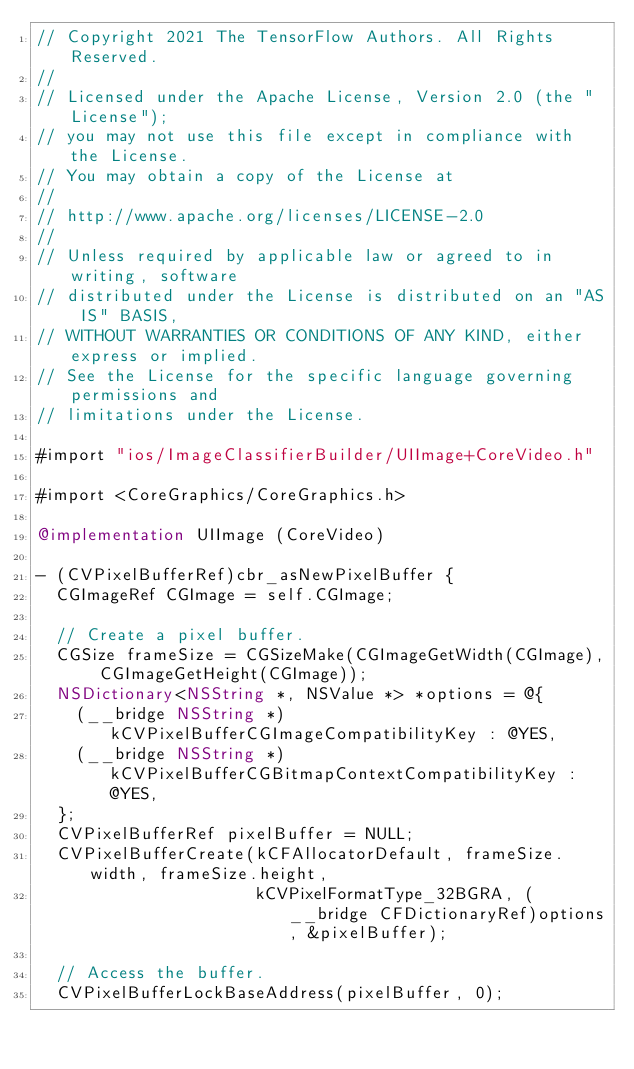Convert code to text. <code><loc_0><loc_0><loc_500><loc_500><_ObjectiveC_>// Copyright 2021 The TensorFlow Authors. All Rights Reserved.
//
// Licensed under the Apache License, Version 2.0 (the "License");
// you may not use this file except in compliance with the License.
// You may obtain a copy of the License at
//
// http://www.apache.org/licenses/LICENSE-2.0
//
// Unless required by applicable law or agreed to in writing, software
// distributed under the License is distributed on an "AS IS" BASIS,
// WITHOUT WARRANTIES OR CONDITIONS OF ANY KIND, either express or implied.
// See the License for the specific language governing permissions and
// limitations under the License.

#import "ios/ImageClassifierBuilder/UIImage+CoreVideo.h"

#import <CoreGraphics/CoreGraphics.h>

@implementation UIImage (CoreVideo)

- (CVPixelBufferRef)cbr_asNewPixelBuffer {
  CGImageRef CGImage = self.CGImage;

  // Create a pixel buffer.
  CGSize frameSize = CGSizeMake(CGImageGetWidth(CGImage), CGImageGetHeight(CGImage));
  NSDictionary<NSString *, NSValue *> *options = @{
    (__bridge NSString *)kCVPixelBufferCGImageCompatibilityKey : @YES,
    (__bridge NSString *)kCVPixelBufferCGBitmapContextCompatibilityKey : @YES,
  };
  CVPixelBufferRef pixelBuffer = NULL;
  CVPixelBufferCreate(kCFAllocatorDefault, frameSize.width, frameSize.height,
                      kCVPixelFormatType_32BGRA, (__bridge CFDictionaryRef)options, &pixelBuffer);

  // Access the buffer.
  CVPixelBufferLockBaseAddress(pixelBuffer, 0);</code> 